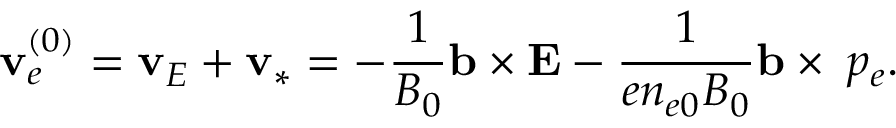Convert formula to latex. <formula><loc_0><loc_0><loc_500><loc_500>v _ { e } ^ { ( 0 ) } = v _ { E } + v _ { * } = - \frac { 1 } { B _ { 0 } } b \times { E } - \frac { 1 } { e n _ { e 0 } B _ { 0 } } b \times \triangle d o w n p _ { e } .</formula> 